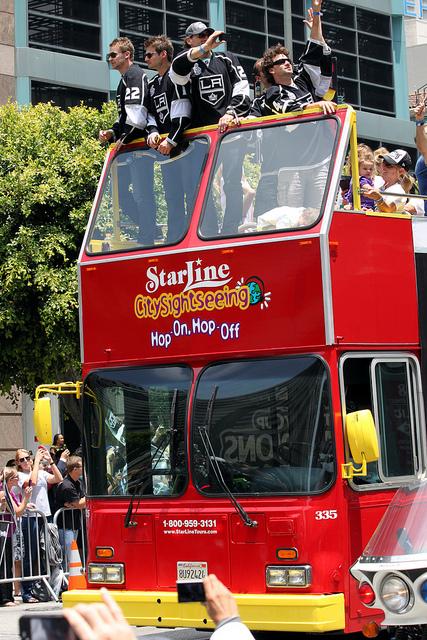How many levels does this bus have?
Quick response, please. 2. What color is the bus?
Concise answer only. Red. Are the people on the top cheering?
Answer briefly. Yes. 